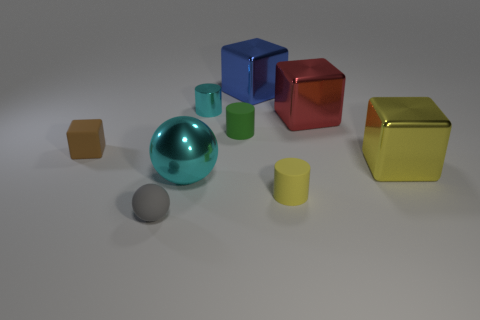If I were to group the objects by their texture, which groups would I have? Based on their texture, you would have two groups: the metallic group, consisting of the cyan sphere, the blue cube, the red cube, and the green cube; and the matte group, containing the yellow cube, the two small brown cubes, the green cylinder, and the small grey sphere. 